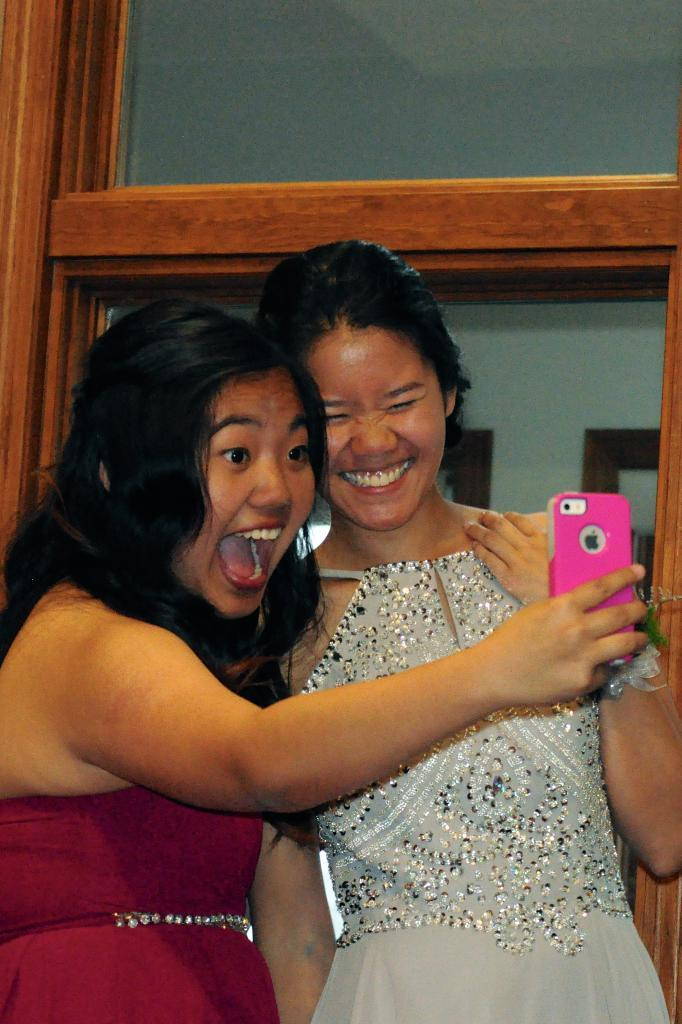How many people are in the image? There are two women in the picture. What are the women doing in the image? The women are taking a selfie with a mobile. What is the facial expression of the women in the image? Both women are smiling. What can be seen in the background of the picture? There is a window in the background of the picture. What type of corn can be seen growing in the background of the image? There is no corn visible in the image; it features two women taking a selfie with a mobile. What scientific experiment is being conducted in the image? There is no scientific experiment being conducted in the image; it shows two women taking a selfie with a mobile. 